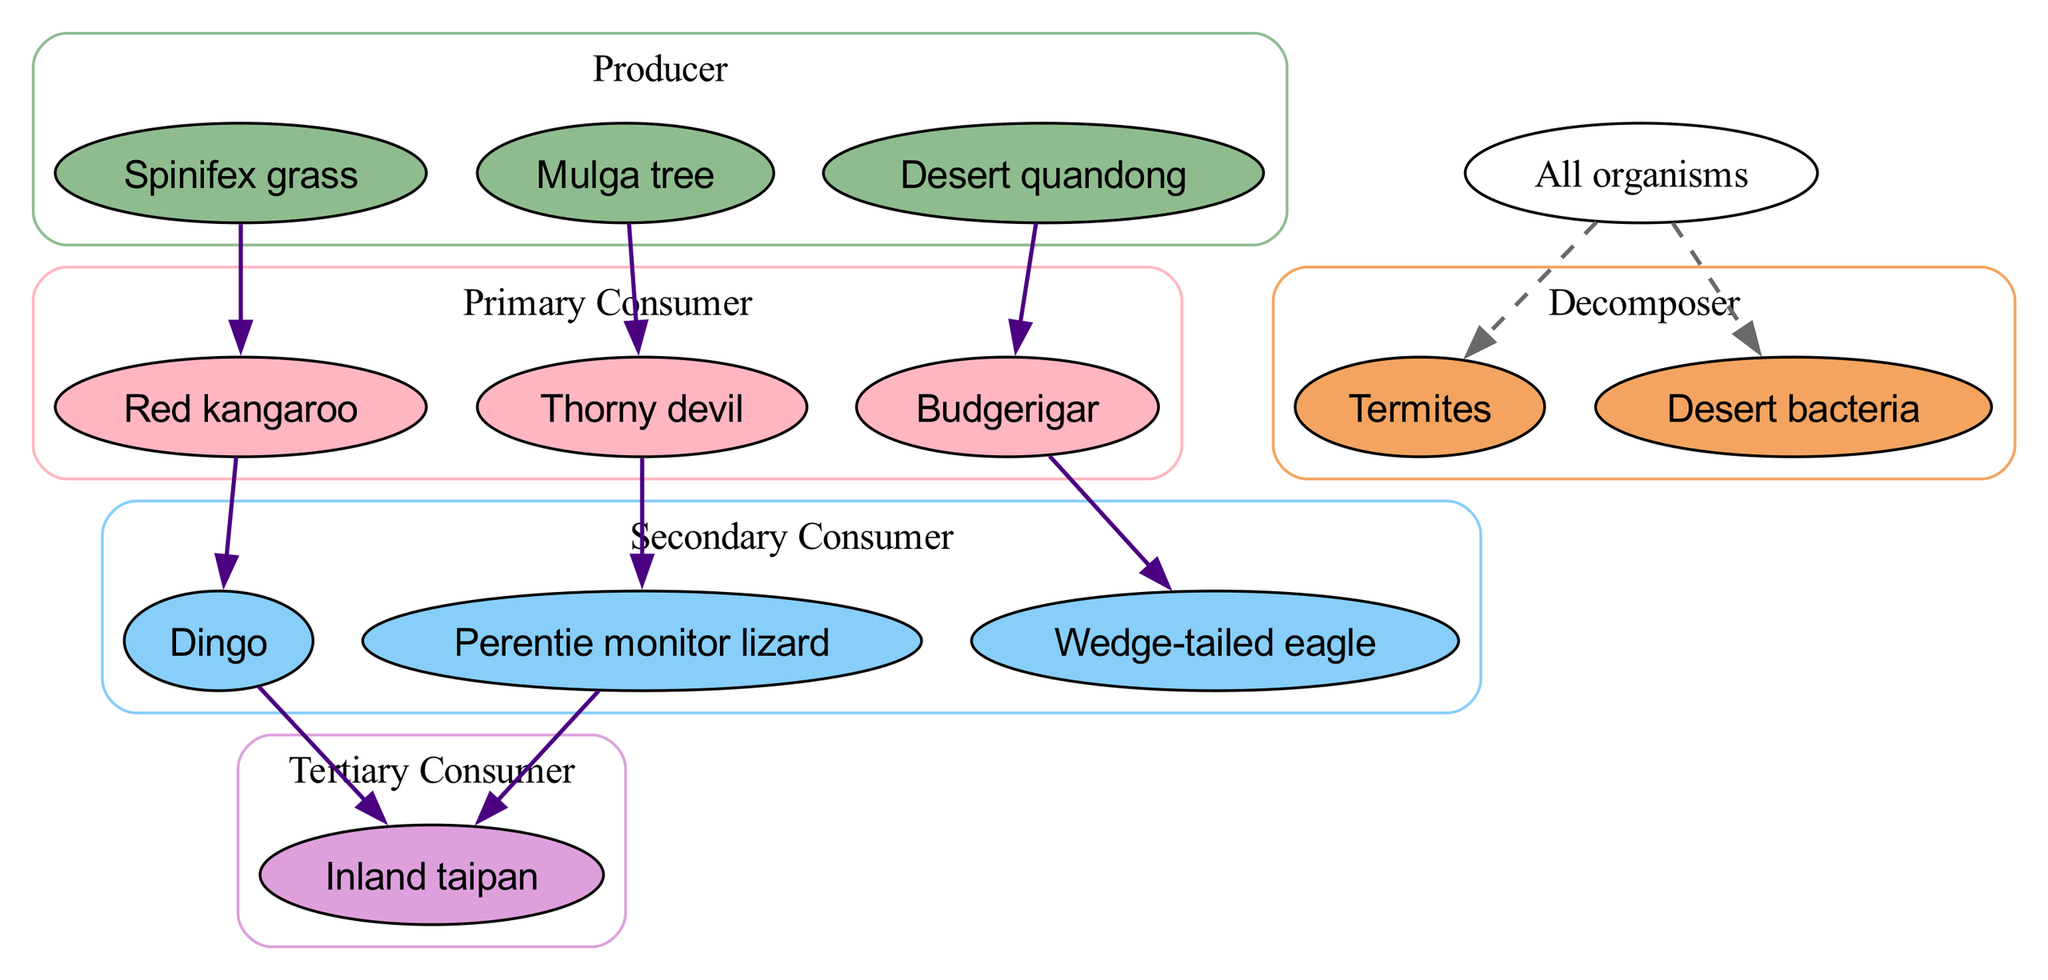What is the producer at the base of the food chain? The food chain lists several producers, but the first one mentioned is Spinifex grass, which provides energy for primary consumers.
Answer: Spinifex grass How many primary consumers are present in the food chain? The diagram contains three primary consumers: Red kangaroo, Thorny devil, and Budgerigar, indicating a diverse range of species that feed on producers.
Answer: 3 Which organism is the top tertiary consumer? The only tertiary consumer listed is the Inland taipan, which feeds on secondary consumers, placing it at the top of this particular food chain.
Answer: Inland taipan What is the relationship between the Red kangaroo and the Dingo? The diagram indicates that the Red kangaroo is a food source for the Dingo, illustrating the predator-prey relationship between these two organisms.
Answer: Red kangaroo → Dingo Name a decomposer in this food chain. The diagram lists two decomposers: Termites and Desert bacteria, which play a crucial role in breaking down organic matter and returning nutrients to the ecosystem.
Answer: Termites Which primary consumer is connected to the Mulga tree? The relationship shows that the Mulga tree serves as food for the Thorny devil, linking the producer to its primary consumer.
Answer: Thorny devil How many edges indicate relationships in the food chain? There are eight distinct relationships indicated by directed edges connecting different organisms, showcasing their interactions as part of the food chain.
Answer: 8 Which secondary consumer eats the Budgerigar? The diagram shows that the Wedge-tailed eagle preys on the Budgerigar, illustrating the flow of energy in the food chain from primary to secondary consumers.
Answer: Wedge-tailed eagle What organisms share the same decomposer? All organisms in the food chain lead to either Termites or Desert bacteria as decomposers, indicating their role in recycling nutrients within the ecosystem.
Answer: All organisms 